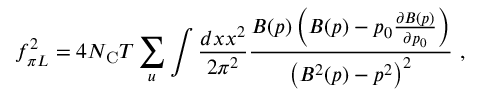Convert formula to latex. <formula><loc_0><loc_0><loc_500><loc_500>f _ { \pi L } ^ { 2 } = 4 N _ { C } T \sum _ { u } \int \frac { d x x ^ { 2 } } { 2 \pi ^ { 2 } } \frac { B ( p ) \left ( B ( p ) - p _ { 0 } \frac { \partial B ( p ) } { \partial p _ { 0 } } \right ) } { \left ( B ^ { 2 } ( p ) - p ^ { 2 } \right ) ^ { 2 } } \ ,</formula> 